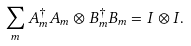Convert formula to latex. <formula><loc_0><loc_0><loc_500><loc_500>\sum _ { m } A _ { m } ^ { \dagger } A _ { m } \otimes B _ { m } ^ { \dagger } B _ { m } = I \otimes I .</formula> 